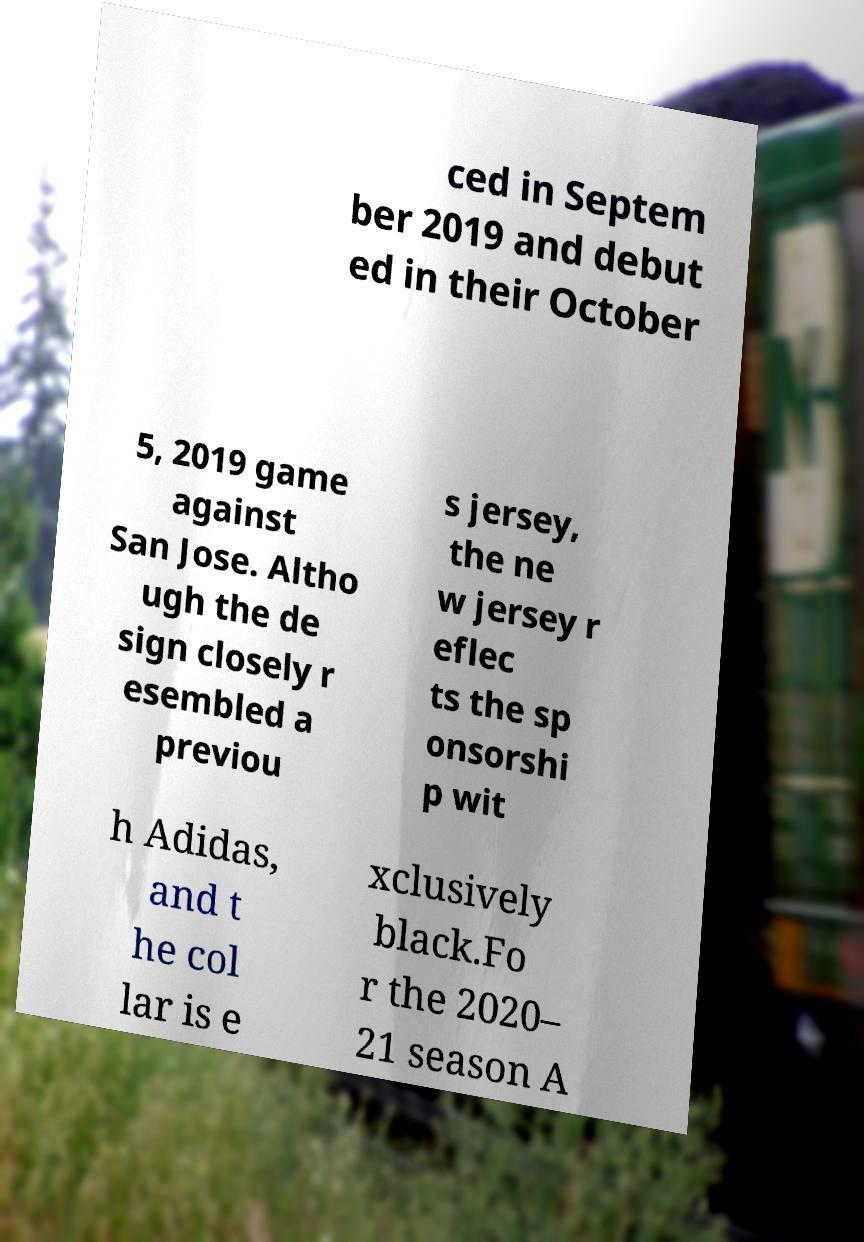There's text embedded in this image that I need extracted. Can you transcribe it verbatim? ced in Septem ber 2019 and debut ed in their October 5, 2019 game against San Jose. Altho ugh the de sign closely r esembled a previou s jersey, the ne w jersey r eflec ts the sp onsorshi p wit h Adidas, and t he col lar is e xclusively black.Fo r the 2020– 21 season A 